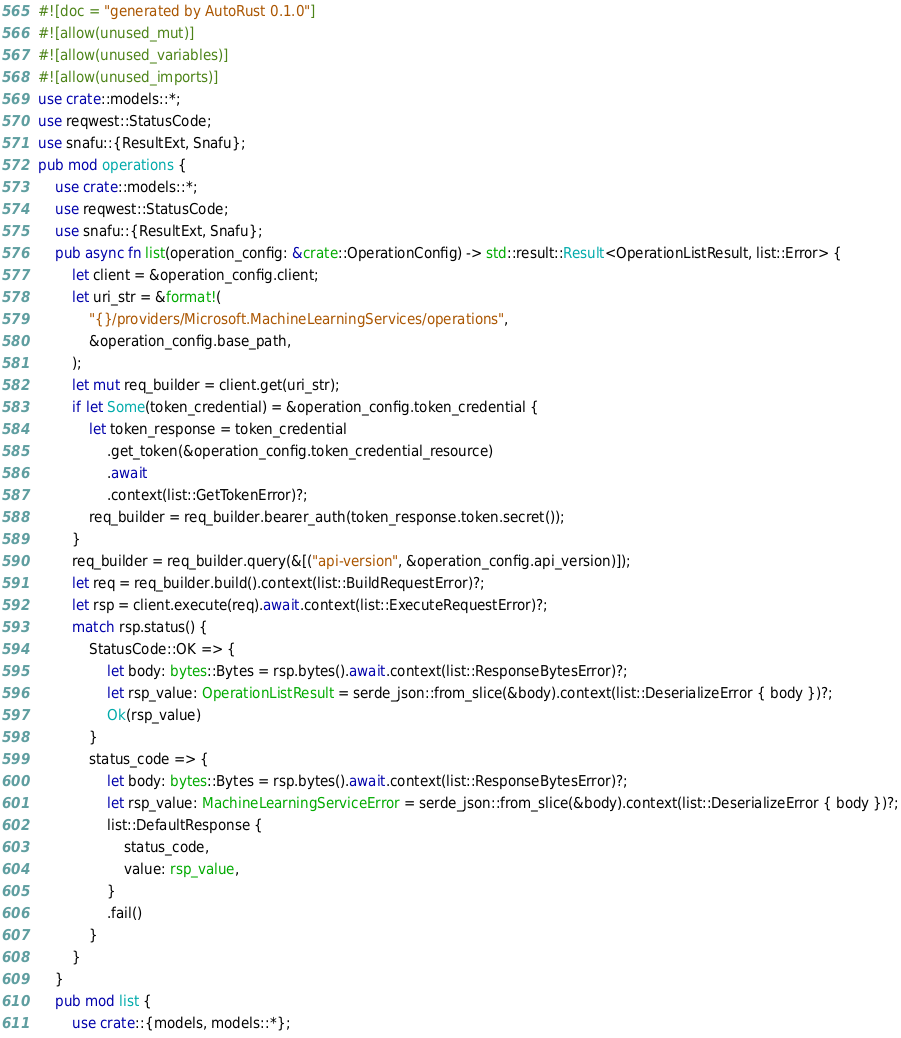Convert code to text. <code><loc_0><loc_0><loc_500><loc_500><_Rust_>#![doc = "generated by AutoRust 0.1.0"]
#![allow(unused_mut)]
#![allow(unused_variables)]
#![allow(unused_imports)]
use crate::models::*;
use reqwest::StatusCode;
use snafu::{ResultExt, Snafu};
pub mod operations {
    use crate::models::*;
    use reqwest::StatusCode;
    use snafu::{ResultExt, Snafu};
    pub async fn list(operation_config: &crate::OperationConfig) -> std::result::Result<OperationListResult, list::Error> {
        let client = &operation_config.client;
        let uri_str = &format!(
            "{}/providers/Microsoft.MachineLearningServices/operations",
            &operation_config.base_path,
        );
        let mut req_builder = client.get(uri_str);
        if let Some(token_credential) = &operation_config.token_credential {
            let token_response = token_credential
                .get_token(&operation_config.token_credential_resource)
                .await
                .context(list::GetTokenError)?;
            req_builder = req_builder.bearer_auth(token_response.token.secret());
        }
        req_builder = req_builder.query(&[("api-version", &operation_config.api_version)]);
        let req = req_builder.build().context(list::BuildRequestError)?;
        let rsp = client.execute(req).await.context(list::ExecuteRequestError)?;
        match rsp.status() {
            StatusCode::OK => {
                let body: bytes::Bytes = rsp.bytes().await.context(list::ResponseBytesError)?;
                let rsp_value: OperationListResult = serde_json::from_slice(&body).context(list::DeserializeError { body })?;
                Ok(rsp_value)
            }
            status_code => {
                let body: bytes::Bytes = rsp.bytes().await.context(list::ResponseBytesError)?;
                let rsp_value: MachineLearningServiceError = serde_json::from_slice(&body).context(list::DeserializeError { body })?;
                list::DefaultResponse {
                    status_code,
                    value: rsp_value,
                }
                .fail()
            }
        }
    }
    pub mod list {
        use crate::{models, models::*};</code> 